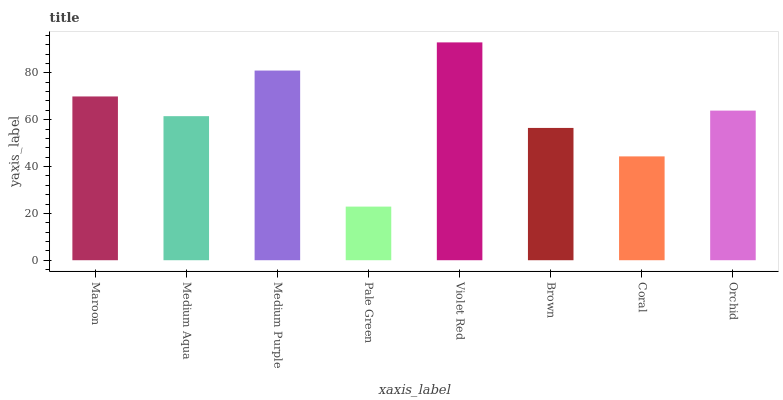Is Pale Green the minimum?
Answer yes or no. Yes. Is Violet Red the maximum?
Answer yes or no. Yes. Is Medium Aqua the minimum?
Answer yes or no. No. Is Medium Aqua the maximum?
Answer yes or no. No. Is Maroon greater than Medium Aqua?
Answer yes or no. Yes. Is Medium Aqua less than Maroon?
Answer yes or no. Yes. Is Medium Aqua greater than Maroon?
Answer yes or no. No. Is Maroon less than Medium Aqua?
Answer yes or no. No. Is Orchid the high median?
Answer yes or no. Yes. Is Medium Aqua the low median?
Answer yes or no. Yes. Is Pale Green the high median?
Answer yes or no. No. Is Violet Red the low median?
Answer yes or no. No. 